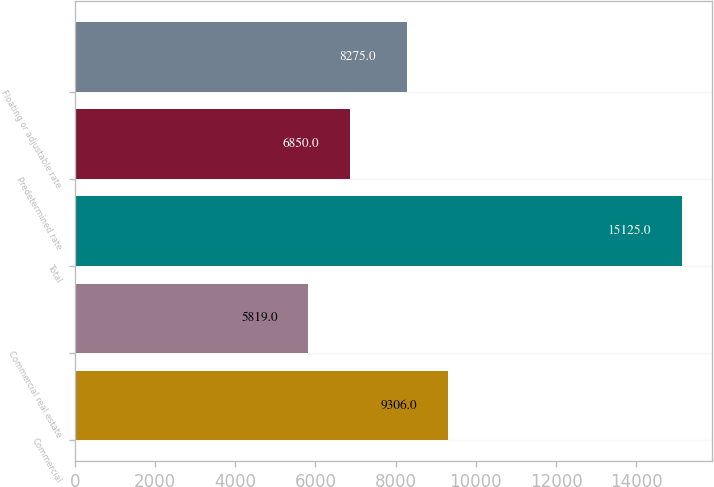Convert chart to OTSL. <chart><loc_0><loc_0><loc_500><loc_500><bar_chart><fcel>Commercial<fcel>Commercial real estate<fcel>Total<fcel>Predetermined rate<fcel>Floating or adjustable rate<nl><fcel>9306<fcel>5819<fcel>15125<fcel>6850<fcel>8275<nl></chart> 